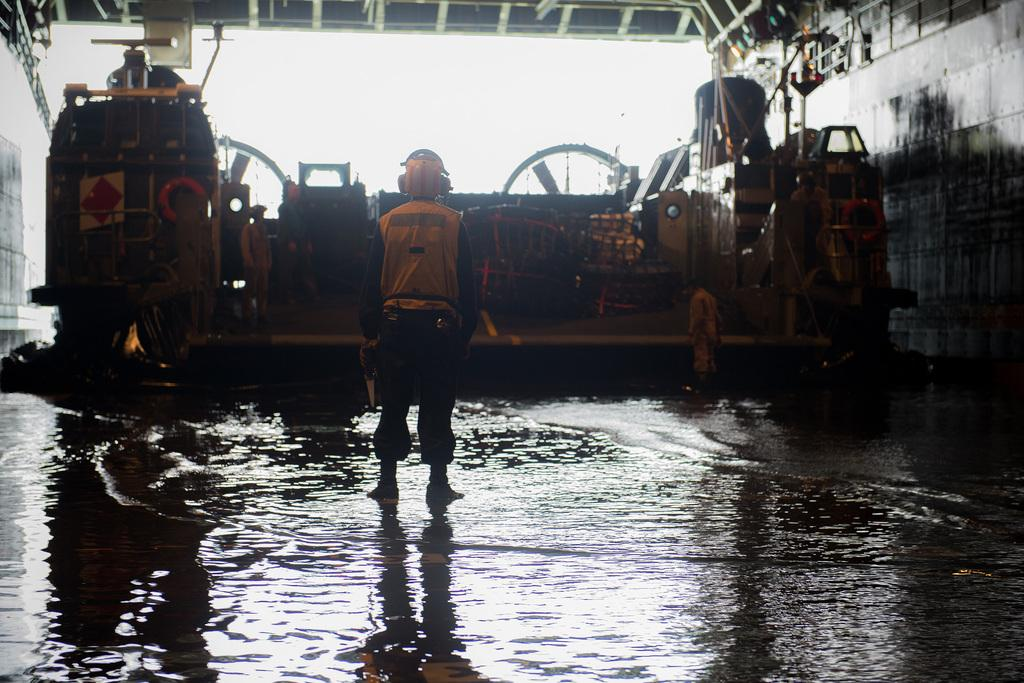How many people are in the image? There is a group of people standing in the image, but the exact number cannot be determined from the provided facts. What is the primary setting of the image? There is water visible in the image, which suggests that the setting is near or on a body of water. What type of vehicle can be seen in the image? There appears to be a vehicle in the image, but the specific type cannot be determined from the provided facts. What type of structure is present in the image? There is a shed in the image. What type of drum is being played by the people in the image? There is no drum present in the image; the people are standing, but no musical instruments are mentioned in the provided facts. 